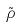<formula> <loc_0><loc_0><loc_500><loc_500>\tilde { \rho }</formula> 